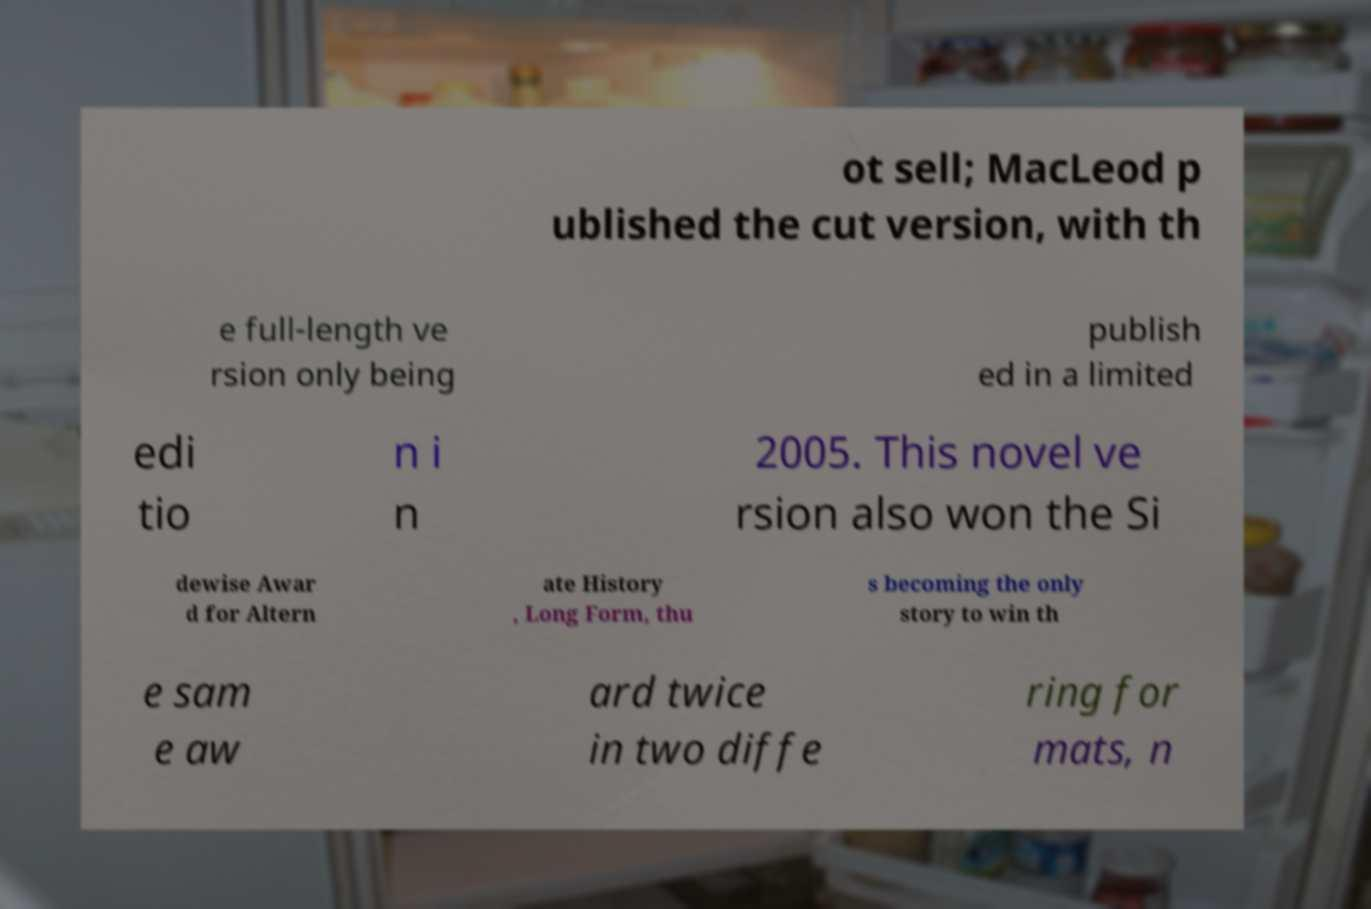There's text embedded in this image that I need extracted. Can you transcribe it verbatim? ot sell; MacLeod p ublished the cut version, with th e full-length ve rsion only being publish ed in a limited edi tio n i n 2005. This novel ve rsion also won the Si dewise Awar d for Altern ate History , Long Form, thu s becoming the only story to win th e sam e aw ard twice in two diffe ring for mats, n 